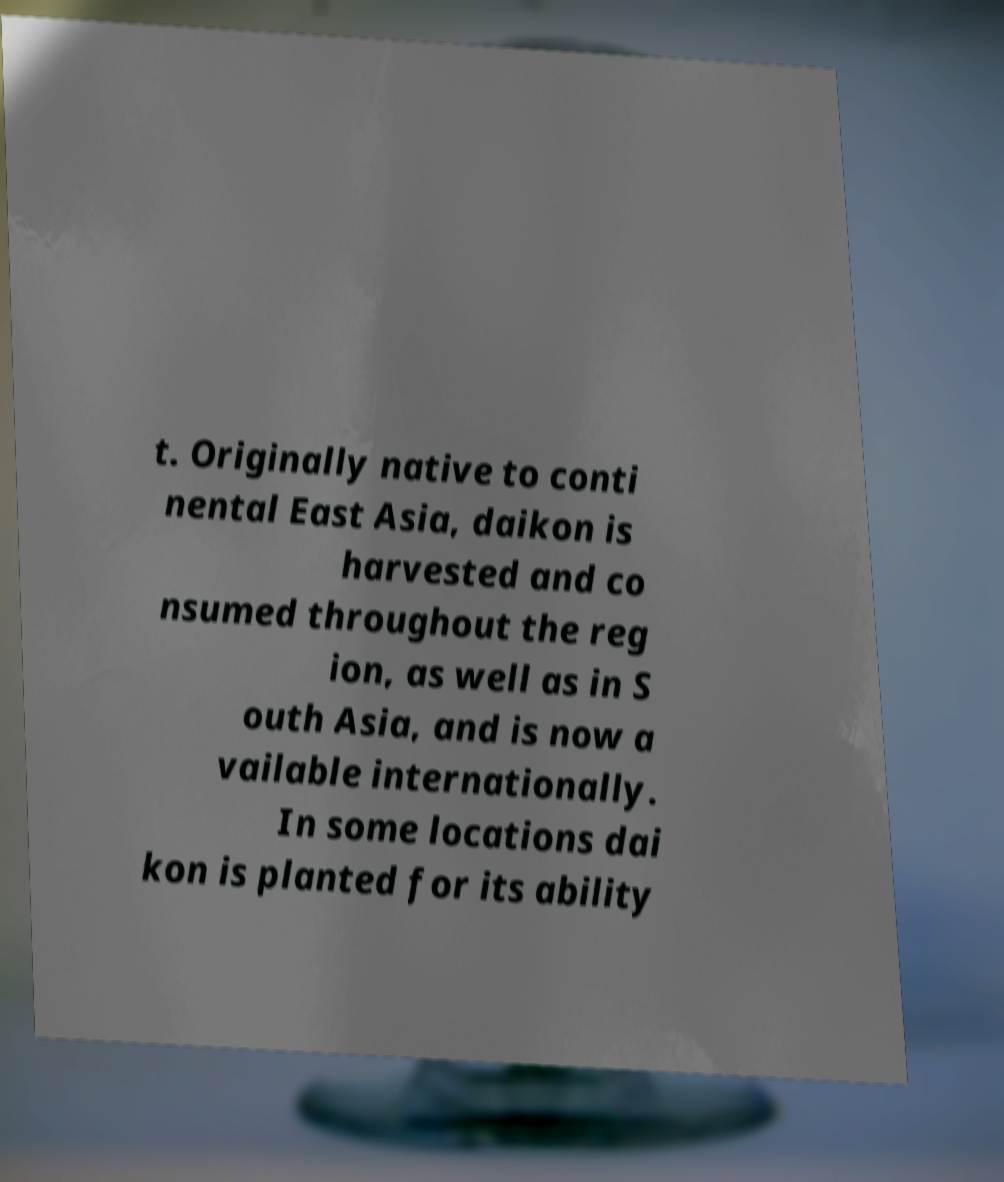Could you extract and type out the text from this image? t. Originally native to conti nental East Asia, daikon is harvested and co nsumed throughout the reg ion, as well as in S outh Asia, and is now a vailable internationally. In some locations dai kon is planted for its ability 